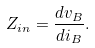<formula> <loc_0><loc_0><loc_500><loc_500>Z _ { i n } = \frac { d v _ { B } } { d i _ { B } } .</formula> 